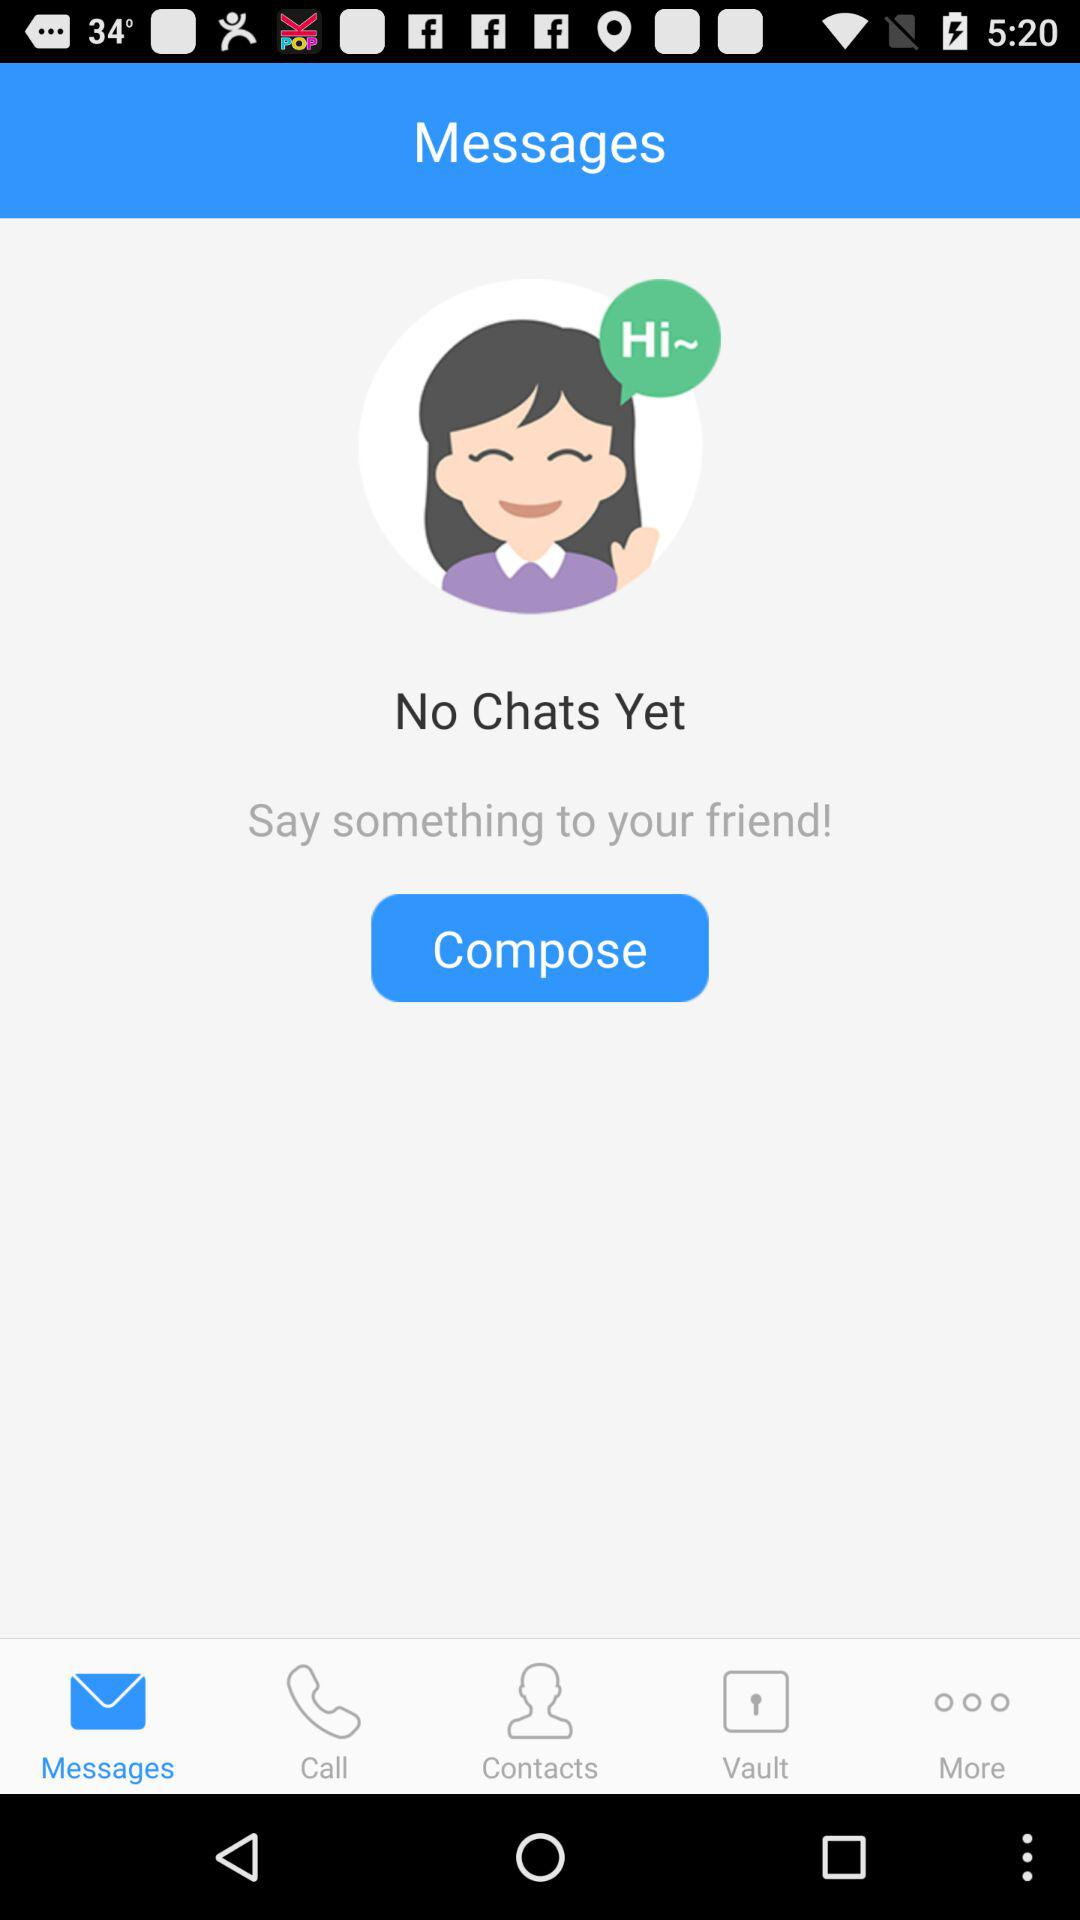Which tab has been selected? The selected tab is "Messages". 